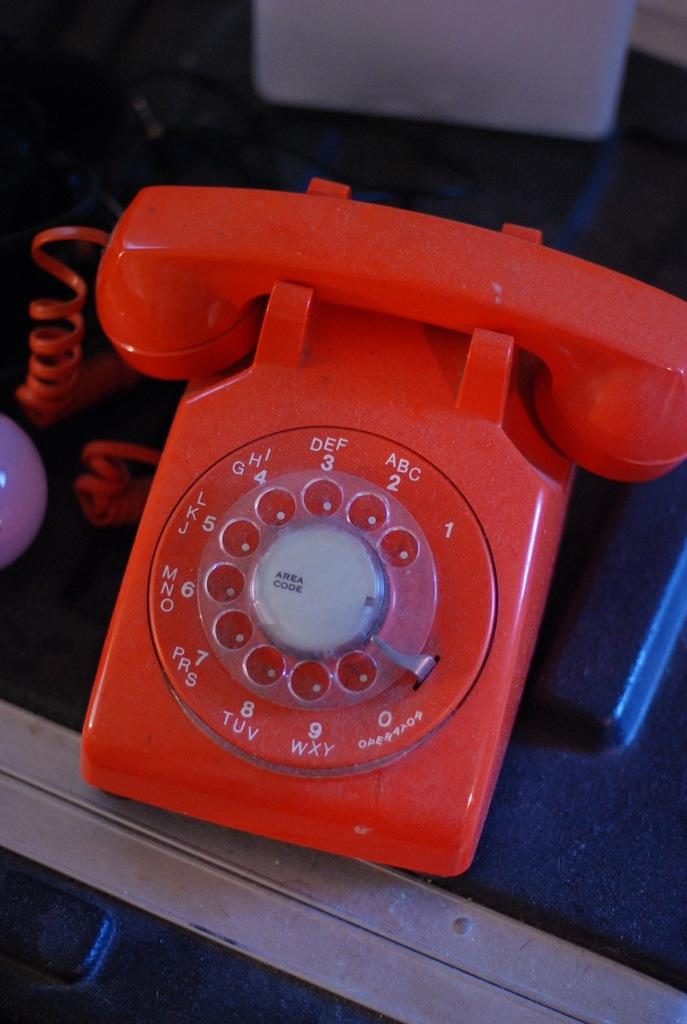What is the color of this phone?
Your answer should be compact. Red. 